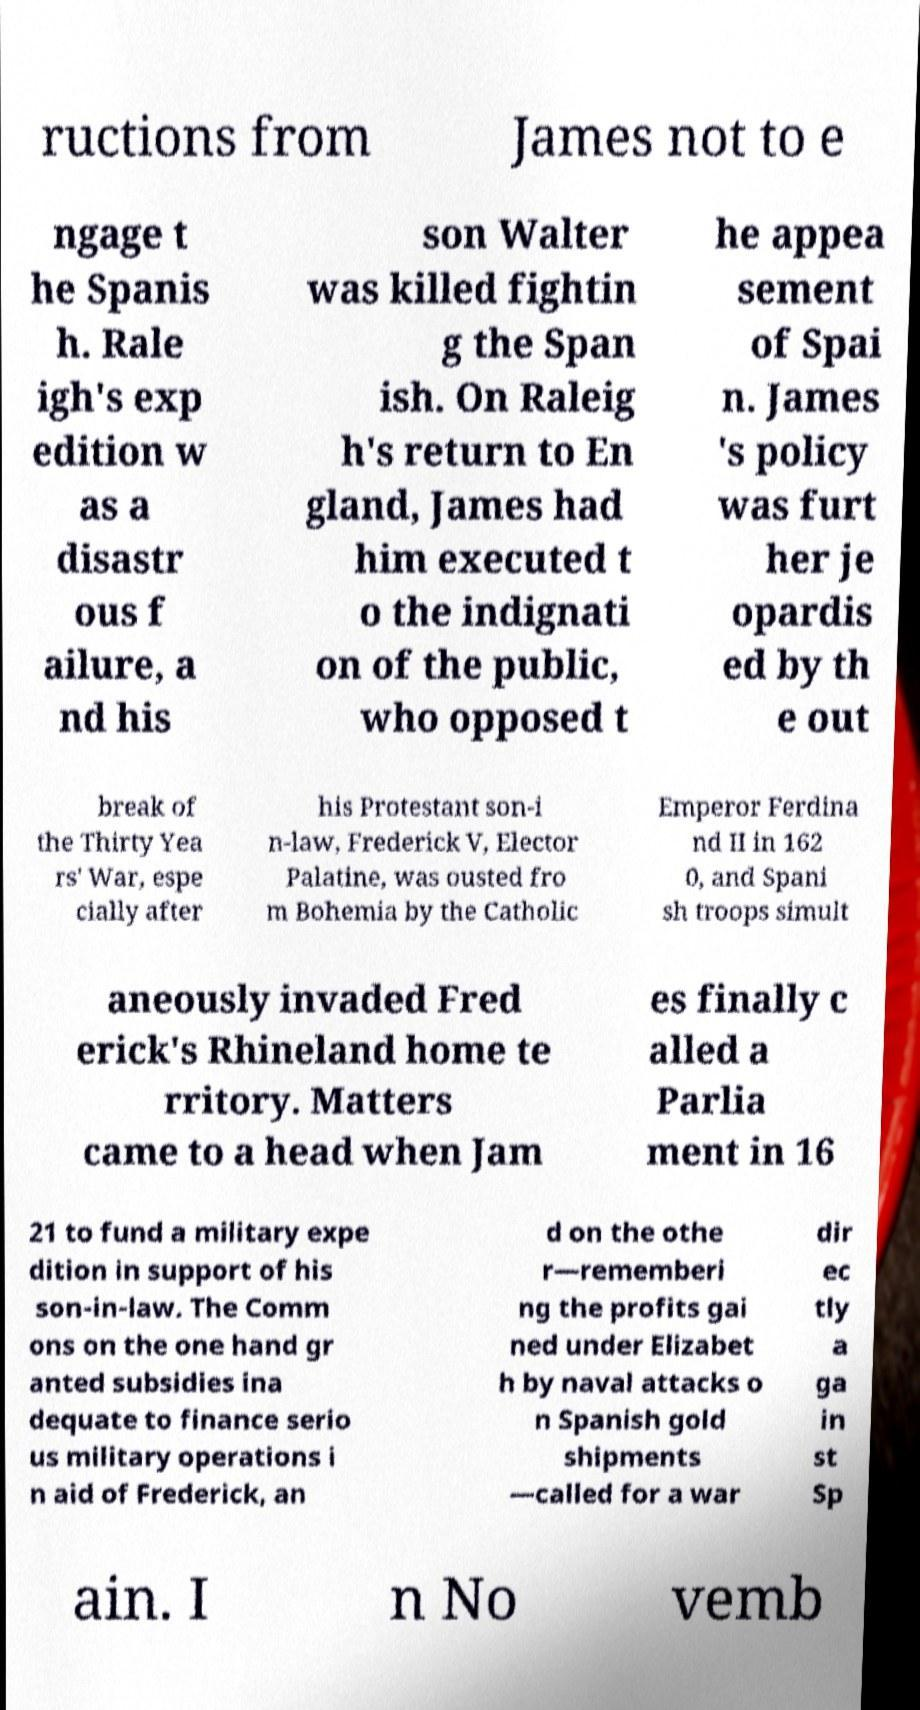Please read and relay the text visible in this image. What does it say? ructions from James not to e ngage t he Spanis h. Rale igh's exp edition w as a disastr ous f ailure, a nd his son Walter was killed fightin g the Span ish. On Raleig h's return to En gland, James had him executed t o the indignati on of the public, who opposed t he appea sement of Spai n. James 's policy was furt her je opardis ed by th e out break of the Thirty Yea rs' War, espe cially after his Protestant son-i n-law, Frederick V, Elector Palatine, was ousted fro m Bohemia by the Catholic Emperor Ferdina nd II in 162 0, and Spani sh troops simult aneously invaded Fred erick's Rhineland home te rritory. Matters came to a head when Jam es finally c alled a Parlia ment in 16 21 to fund a military expe dition in support of his son-in-law. The Comm ons on the one hand gr anted subsidies ina dequate to finance serio us military operations i n aid of Frederick, an d on the othe r—rememberi ng the profits gai ned under Elizabet h by naval attacks o n Spanish gold shipments —called for a war dir ec tly a ga in st Sp ain. I n No vemb 